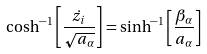<formula> <loc_0><loc_0><loc_500><loc_500>\cosh ^ { - 1 } \left [ \frac { \dot { z _ { i } } } { \sqrt { a _ { \alpha } } } \right ] = \sinh ^ { - 1 } \left [ \frac { \beta _ { \alpha } } { a _ { \alpha } } \right ]</formula> 